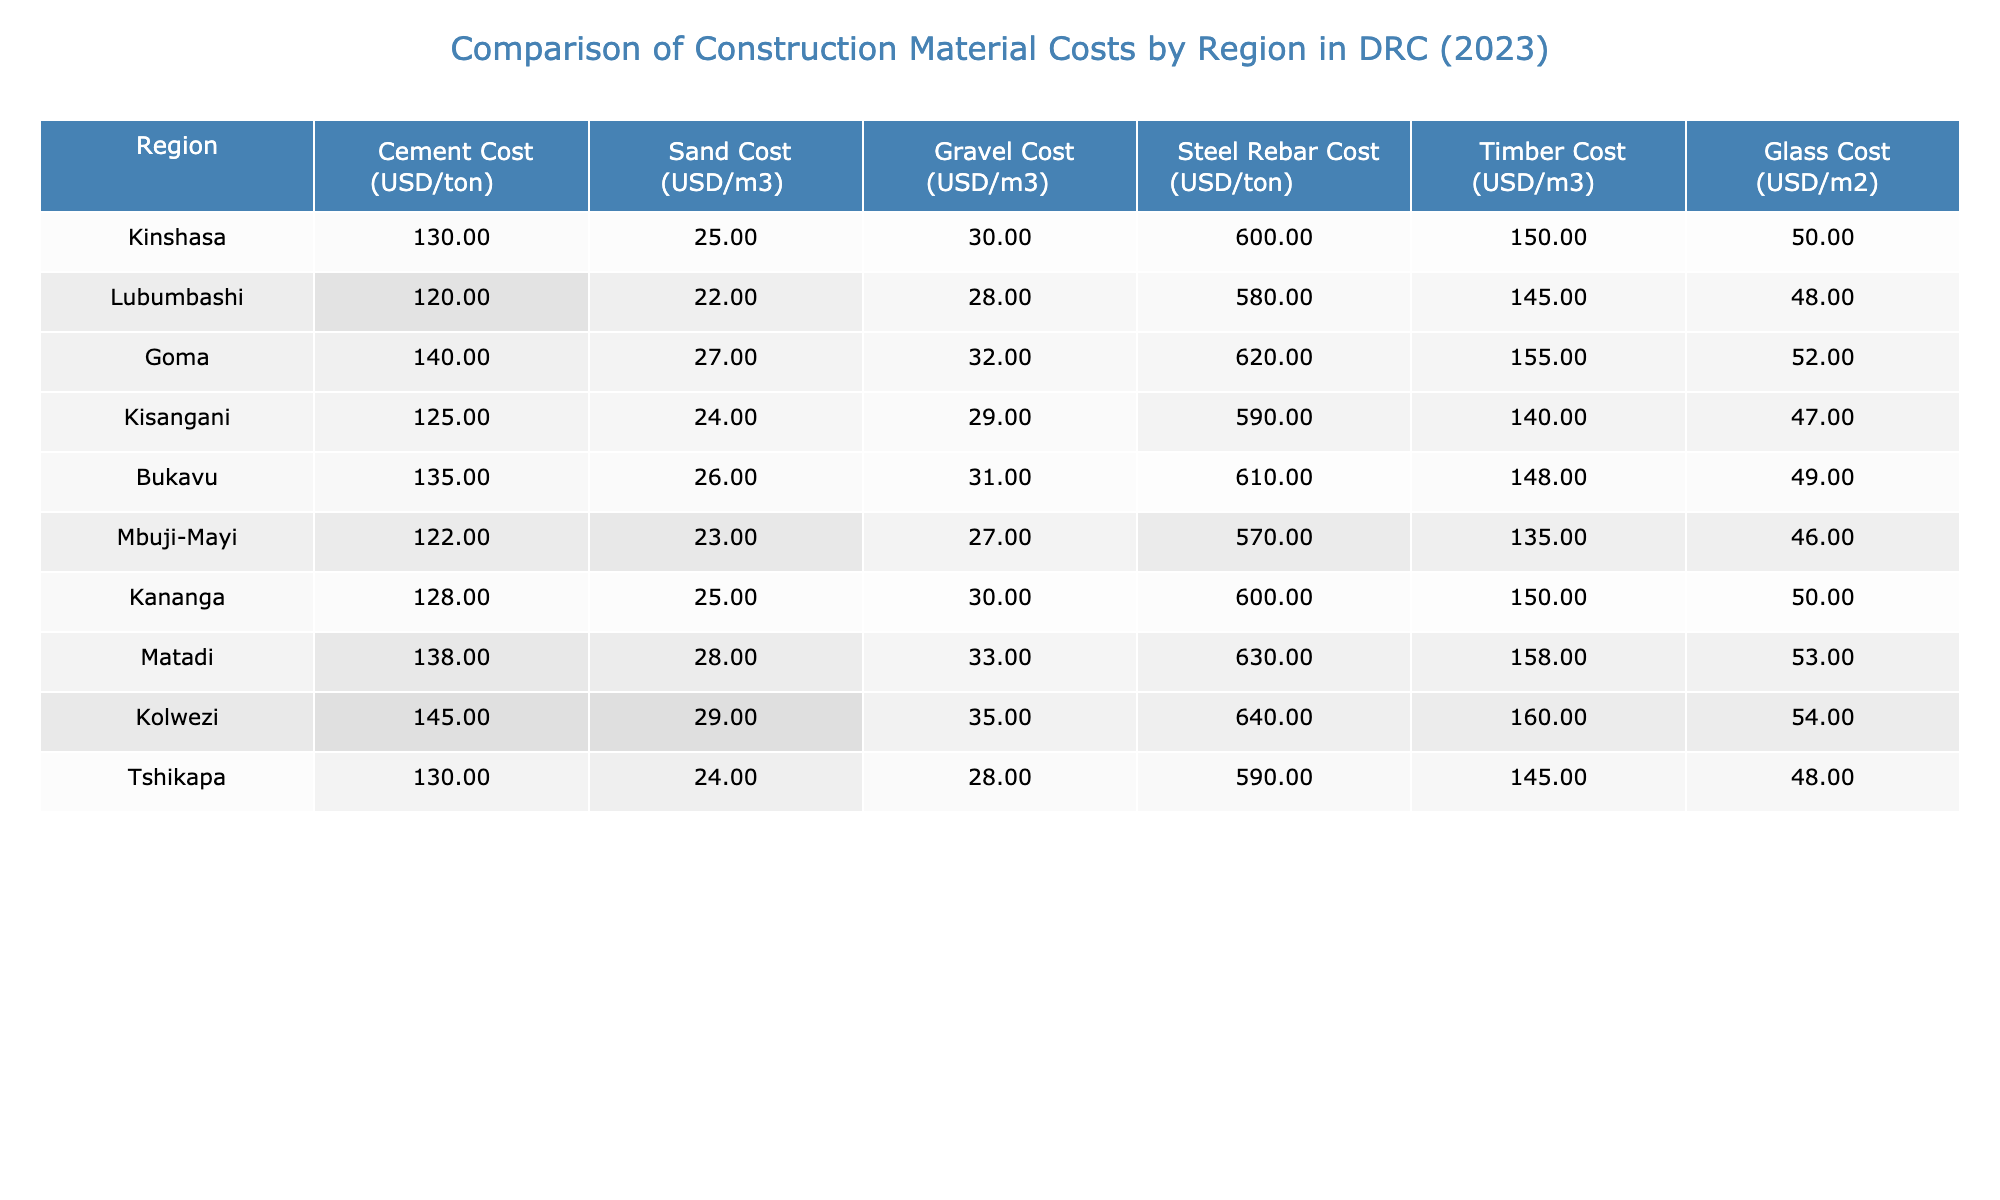What is the cost of cement in Kinshasa? According to the table, the cement cost in Kinshasa is listed as 130 USD per ton.
Answer: 130 USD/ton Which region has the highest cost for steel rebar? By examining the table, I see that Kolwezi has the highest cost for steel rebar at 640 USD per ton.
Answer: Kolwezi What is the difference in sand costs between Goma and Mbuji-Mayi? Goma has a sand cost of 27 USD/m3 and Mbuji-Mayi has a sand cost of 23 USD/m3. The difference is 27 - 23 = 4 USD/m3.
Answer: 4 USD/m3 Is the cost of glass in Bukavu higher than in Lubumbashi? In the table, Bukavu's glass cost is 49 USD/m2 while Lubumbashi's is 48 USD/m2. Since 49 is greater than 48, the statement is true.
Answer: Yes Calculate the average gravel cost across all regions. To find the average, I sum the gravel costs for all regions: (30 + 28 + 32 + 29 + 31 + 27 + 30 + 33 + 35 + 28) =  30.3. Then, divide by the number of regions (10): 303/10 = 30.3 USD/m3.
Answer: 30.3 USD/m3 Which region has the lowest cost for timber? Looking through the table, Mbuji-Mayi has the lowest cost for timber at 135 USD/m3.
Answer: Mbuji-Mayi Are the costs of all materials higher in Kolwezi compared to Tshikapa? When comparing the costs for each material side by side, Kolwezi (Cement: 145, Sand: 29, Gravel: 35, Steel Rebar: 640, Timber: 160, Glass: 54) is higher than Tshikapa (Cement: 130, Sand: 24, Gravel: 28, Steel Rebar: 590, Timber: 145, Glass: 48) for all materials. Therefore, the statement is true.
Answer: Yes What is the total cost of cement and timber in Kinshasa? In Kinshasa, the cement cost is 130 USD/ton and the timber cost is 150 USD/m3, summing them gives 130 + 150 = 280 USD.
Answer: 280 USD Is the average cement cost in DRC closer to 125 or 135 USD per ton? The average cement cost can be calculated by summing the costs: (130 + 120 + 140 + 125 + 135 + 122 + 128 + 138 + 145 + 130) = 1320 USD. Dividing by 10 gives an average of 132 USD, which is closer to 135 USD.
Answer: 135 USD/ton What is the highest cost of glass among all the regions? By assessing the glass costs from each region, Kolwezi has the highest cost at 54 USD/m2.
Answer: 54 USD/m2 